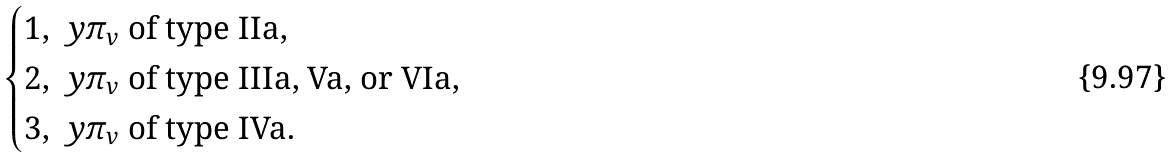<formula> <loc_0><loc_0><loc_500><loc_500>\begin{cases} 1 , \ y \text {$\pi_{v}$ of type IIa,} \\ 2 , \ y \text {$\pi_{v}$ of type IIIa, Va, or VIa,} \\ 3 , \ y \text {$\pi_{v}$ of type IVa.} \\ \end{cases}</formula> 